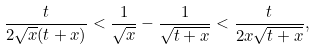Convert formula to latex. <formula><loc_0><loc_0><loc_500><loc_500>\frac { t } { 2 \sqrt { x } ( t + x ) } < \frac { 1 } { \sqrt { x } } - \frac { 1 } { \sqrt { t + x } } < \frac { t } { 2 x \sqrt { t + x } } ,</formula> 